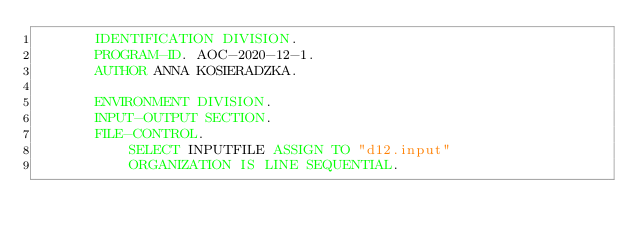<code> <loc_0><loc_0><loc_500><loc_500><_COBOL_>       IDENTIFICATION DIVISION.
       PROGRAM-ID. AOC-2020-12-1.
       AUTHOR ANNA KOSIERADZKA.
      
       ENVIRONMENT DIVISION.
       INPUT-OUTPUT SECTION.
       FILE-CONTROL.
           SELECT INPUTFILE ASSIGN TO "d12.input"
           ORGANIZATION IS LINE SEQUENTIAL.
           </code> 